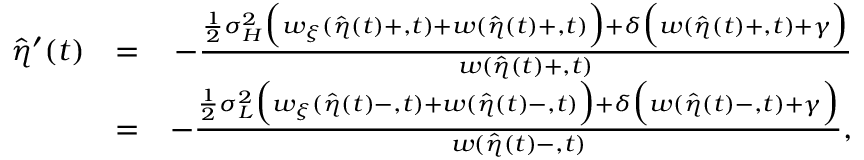Convert formula to latex. <formula><loc_0><loc_0><loc_500><loc_500>\begin{array} { r l r } { \hat { \eta } ^ { \prime } ( t ) } & { = } & { - \frac { \frac { 1 } { 2 } { \sigma } _ { H } ^ { 2 } \left ( w _ { \xi } ( \hat { \eta } ( t ) + , t ) + w ( \hat { \eta } ( t ) + , t ) \right ) + \delta \left ( w ( \hat { \eta } ( t ) + , t ) + \gamma \right ) } { w ( \hat { \eta } ( t ) + , t ) } } \\ & { = } & { - \frac { \frac { 1 } { 2 } { \sigma } _ { L } ^ { 2 } \left ( w _ { \xi } ( \hat { \eta } ( t ) - , t ) + w ( \hat { \eta } ( t ) - , t ) \right ) + \delta \left ( w ( \hat { \eta } ( t ) - , t ) + \gamma \right ) } { w ( \hat { \eta } ( t ) - , t ) } , } \end{array}</formula> 